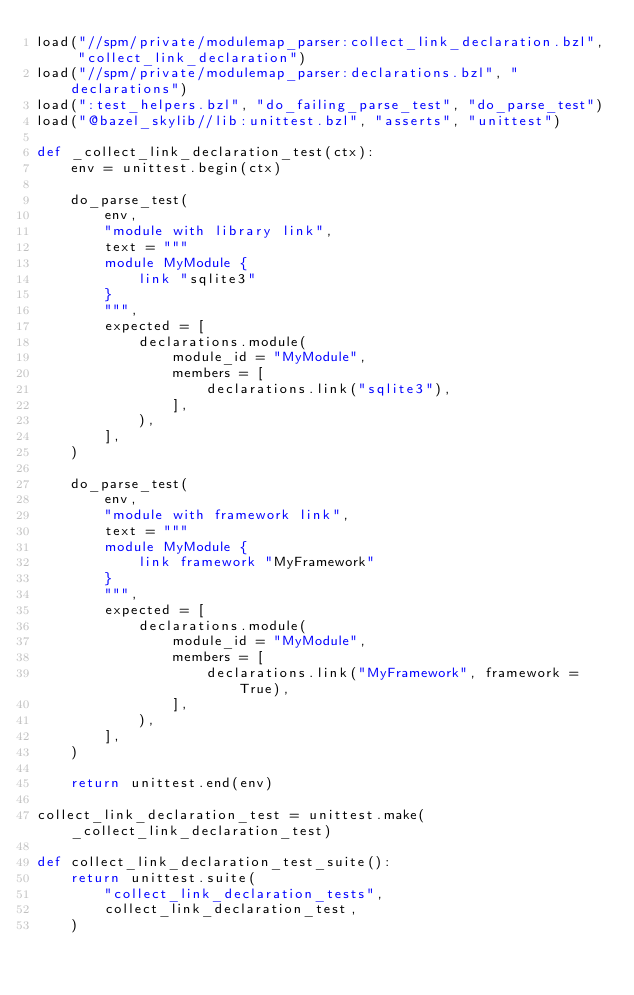<code> <loc_0><loc_0><loc_500><loc_500><_Python_>load("//spm/private/modulemap_parser:collect_link_declaration.bzl", "collect_link_declaration")
load("//spm/private/modulemap_parser:declarations.bzl", "declarations")
load(":test_helpers.bzl", "do_failing_parse_test", "do_parse_test")
load("@bazel_skylib//lib:unittest.bzl", "asserts", "unittest")

def _collect_link_declaration_test(ctx):
    env = unittest.begin(ctx)

    do_parse_test(
        env,
        "module with library link",
        text = """
        module MyModule {
            link "sqlite3"
        }
        """,
        expected = [
            declarations.module(
                module_id = "MyModule",
                members = [
                    declarations.link("sqlite3"),
                ],
            ),
        ],
    )

    do_parse_test(
        env,
        "module with framework link",
        text = """
        module MyModule {
            link framework "MyFramework"
        }
        """,
        expected = [
            declarations.module(
                module_id = "MyModule",
                members = [
                    declarations.link("MyFramework", framework = True),
                ],
            ),
        ],
    )

    return unittest.end(env)

collect_link_declaration_test = unittest.make(_collect_link_declaration_test)

def collect_link_declaration_test_suite():
    return unittest.suite(
        "collect_link_declaration_tests",
        collect_link_declaration_test,
    )
</code> 